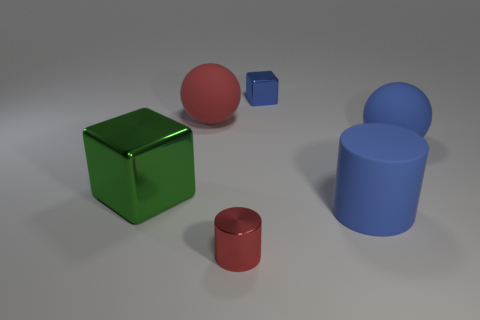What is the size of the blue metal thing?
Provide a succinct answer. Small. There is a green metal object that is the same size as the red matte thing; what shape is it?
Make the answer very short. Cube. Is the sphere right of the blue block made of the same material as the big green object to the left of the red rubber sphere?
Your answer should be very brief. No. Is there a blue rubber object in front of the large blue matte thing that is behind the big cube?
Your answer should be very brief. Yes. The big thing that is made of the same material as the small cube is what color?
Provide a succinct answer. Green. Is the number of blocks greater than the number of yellow cylinders?
Your response must be concise. Yes. How many objects are either blocks that are in front of the tiny blue thing or large red spheres?
Your answer should be compact. 2. Is there a blue metallic thing that has the same size as the rubber cylinder?
Your response must be concise. No. Is the number of rubber objects less than the number of big things?
Provide a short and direct response. Yes. How many cubes are either large blue objects or large green metallic objects?
Make the answer very short. 1. 